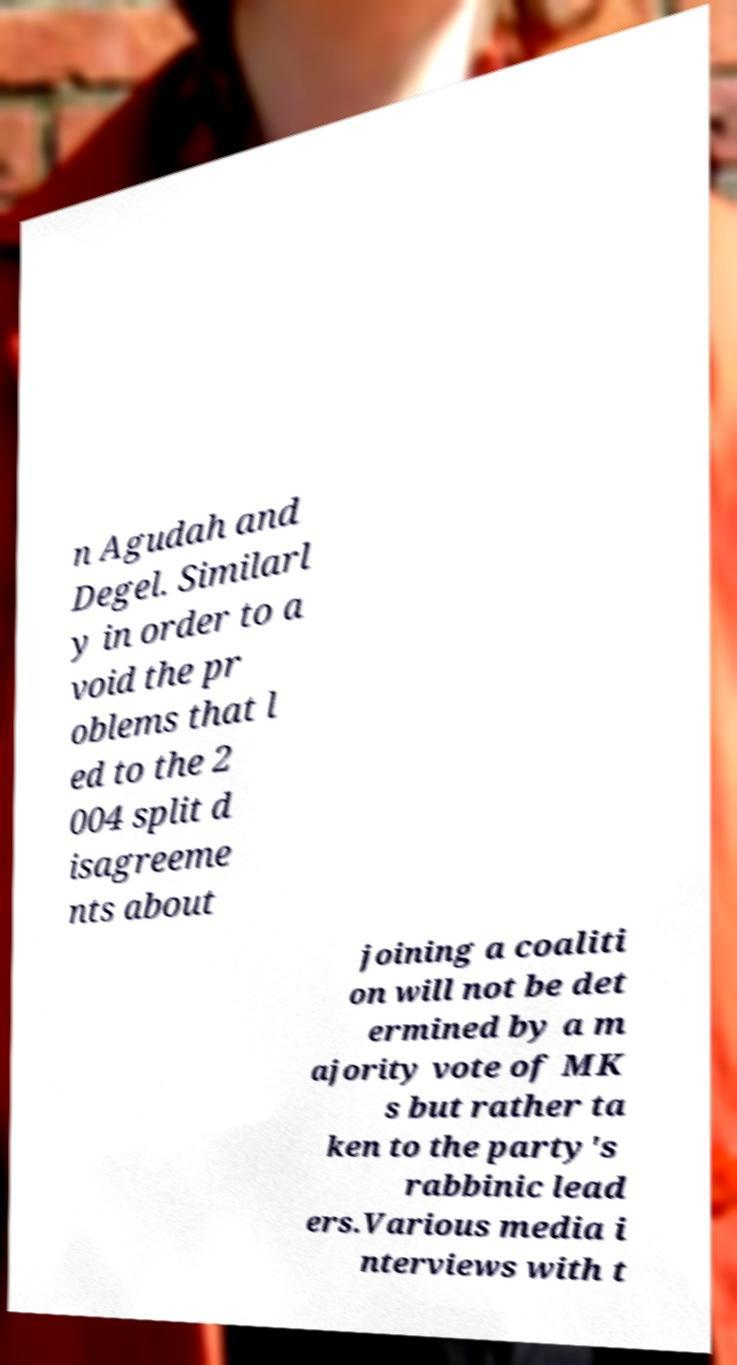Can you accurately transcribe the text from the provided image for me? n Agudah and Degel. Similarl y in order to a void the pr oblems that l ed to the 2 004 split d isagreeme nts about joining a coaliti on will not be det ermined by a m ajority vote of MK s but rather ta ken to the party's rabbinic lead ers.Various media i nterviews with t 